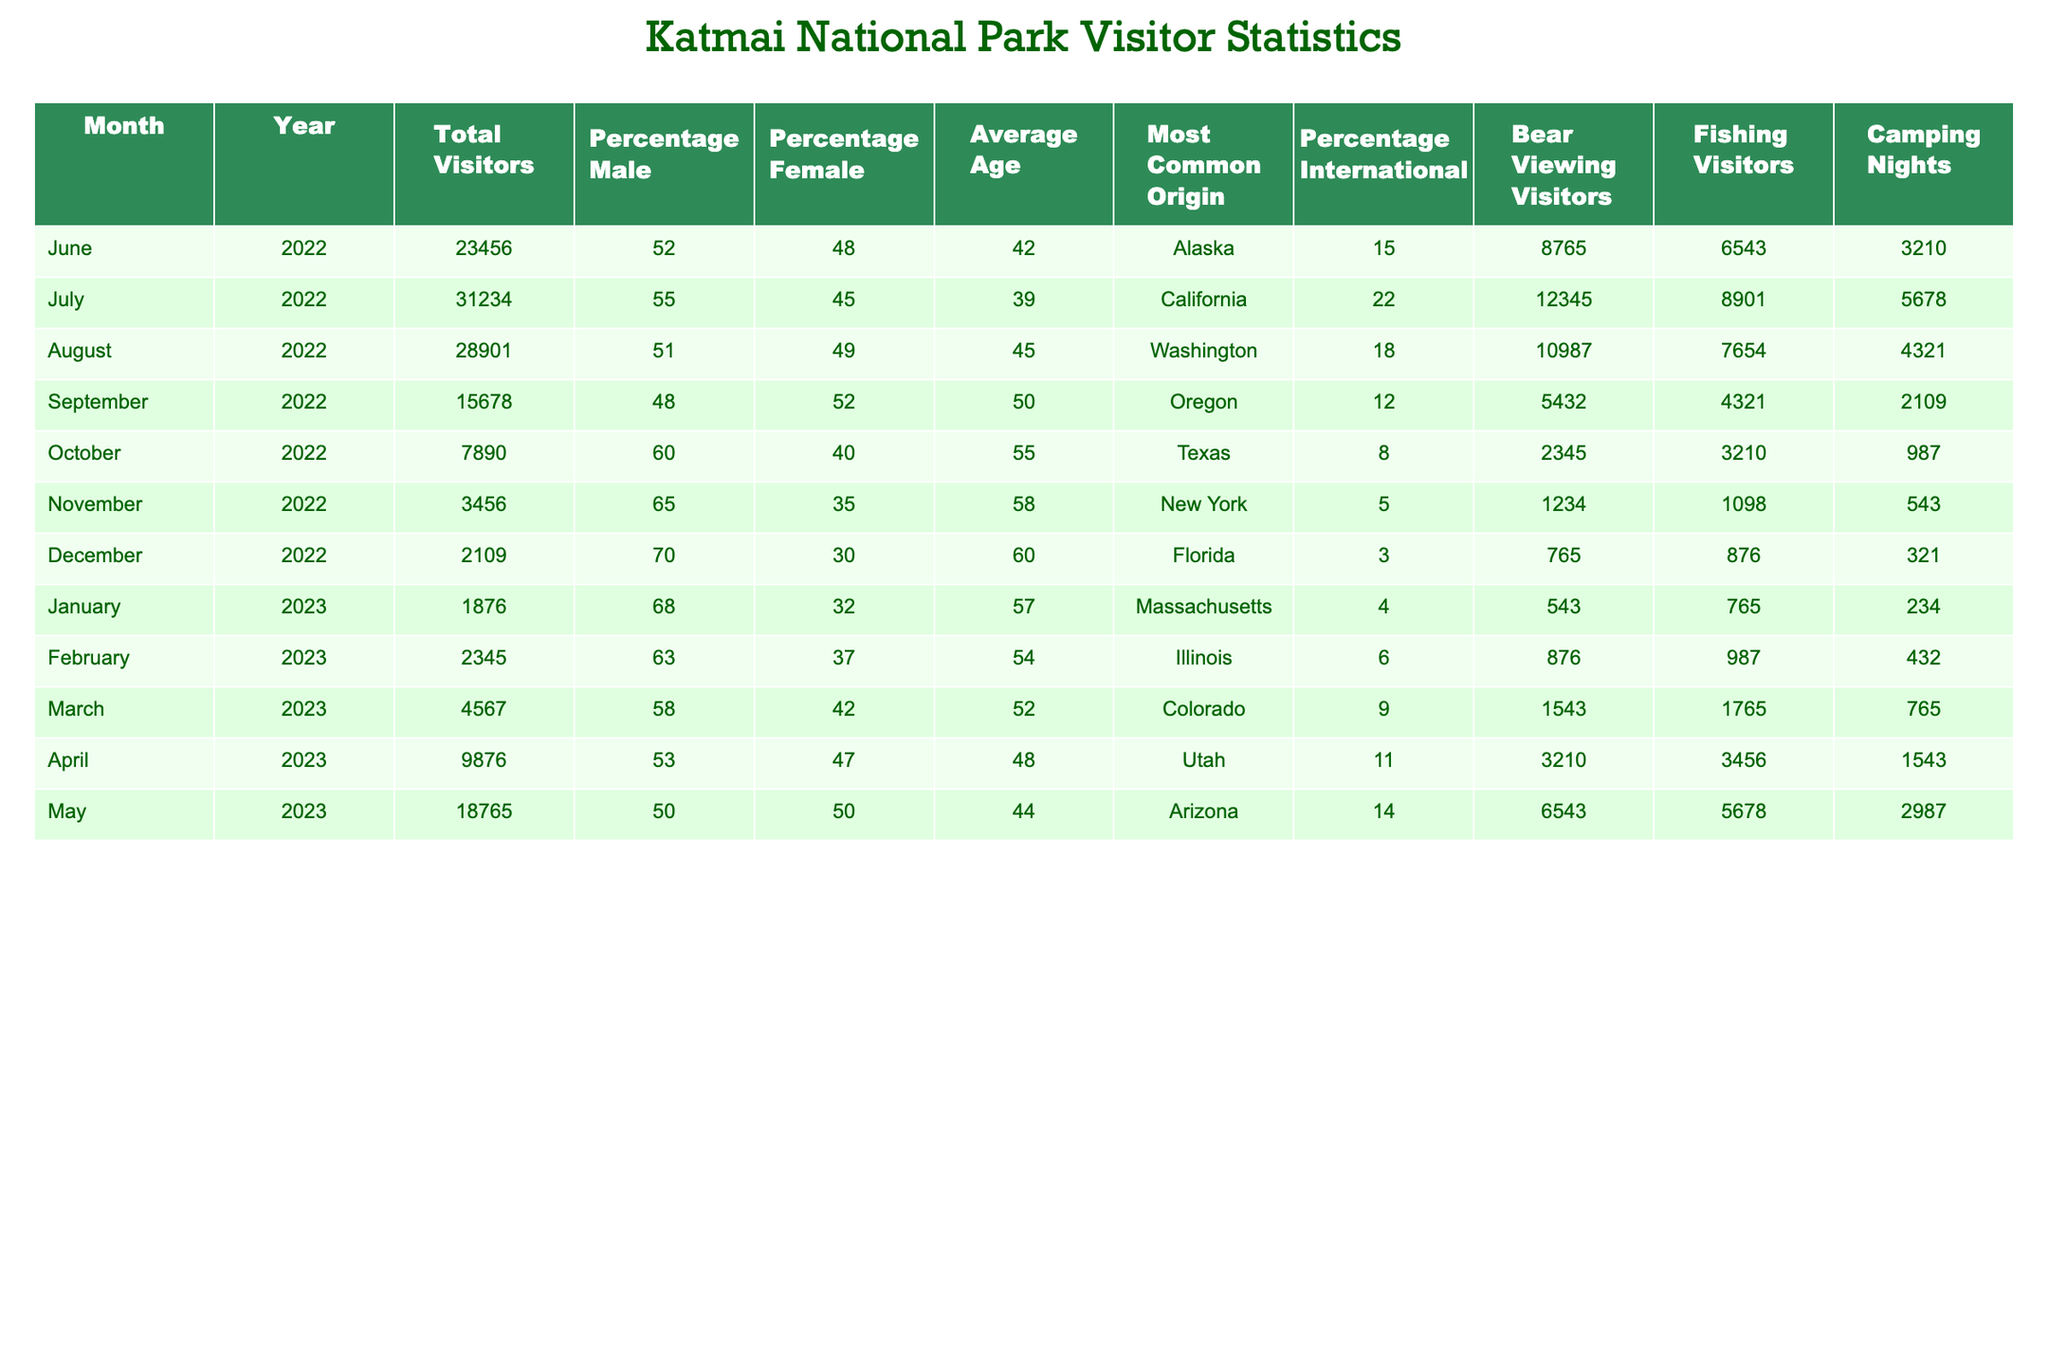What was the total number of visitors in July 2022? The table states that the total visitors for July 2022 is listed under the "Total Visitors" column for that month, which shows a value of 31234.
Answer: 31234 What percentage of visitors were female in September 2022? According to the table, the percentage of female visitors in September 2022 is found in the "Percentage Female" column, which indicates a value of 52%.
Answer: 52% In which month did Katmai National Park have the highest average age of visitors? To find the month with the highest average age, I compare the "Average Age" values across all months. The value is highest at 60 in December 2022.
Answer: December 2022 How many camping nights were recorded in May 2023? The table shows the number of camping nights for May 2023 listed as 2987 under the "Camping Nights" column.
Answer: 2987 What is the total number of bear viewing visitors from January to March 2023? To find the total for bear viewing visitors from January to March 2023, I sum the values for these months: 543 + 876 + 1543 = 1962.
Answer: 1962 Was the percentage of international visitors highest in July or August 2022? Looking at the "Percentage International" column, July 2022 has 22% and August 2022 has 18%. Since 22% is higher, July is the month with the highest percentage.
Answer: Yes, it was highest in July 2022 What is the average percentage of male visitors for the year 2022? To calculate the average percentage of male visitors for 2022, I total the percentages from June to December 2022 (52 + 55 + 51 + 48 + 60 + 65 + 70) = 401 and divide by 7 months, resulting in 401 / 7 ≈ 57.29%.
Answer: Approximately 57.29% How does the percentage of male visitors in January 2023 compare to that in May 2023? The table shows 68% male visitors in January 2023 and 50% in May 2023. Since 68% is higher than 50%, January has a higher percentage of male visitors.
Answer: January has a higher percentage What was the most common origin of visitors in October 2022? According to the table, the most common origin of visitors in October 2022 is listed under the "Most Common Origin" column, which indicates Texas.
Answer: Texas Did the total number of visitors decrease from August to September 2022? By comparing the totals, August 2022 had 28901 visitors, while September 2022 had 15678. Since 15678 is less than 28901, the total number of visitors did decrease.
Answer: Yes, it decreased What is the total number of fishing visitors for the entire year of 2022? To find the total number of fishing visitors for 2022, I sum the fishing visitors from June to December: 6543 + 8901 + 7654 + 4321 + 3210 + 1098 + 876. The total is 28103.
Answer: 28103 